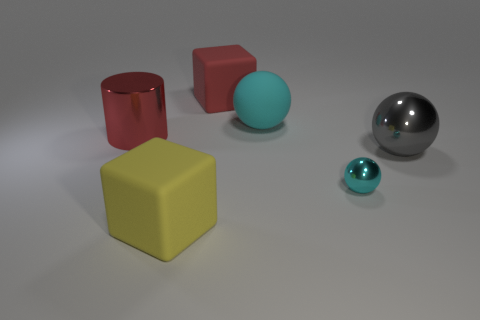What is the size of the thing that is the same color as the big cylinder?
Make the answer very short. Large. What is the material of the big thing that is the same color as the metal cylinder?
Your response must be concise. Rubber. What is the material of the large cyan object that is the same shape as the big gray metallic thing?
Keep it short and to the point. Rubber. Are there any big cyan things in front of the cyan matte thing?
Keep it short and to the point. No. Are the big cube that is behind the cyan rubber sphere and the tiny cyan object made of the same material?
Provide a short and direct response. No. Is there another big metallic cylinder that has the same color as the cylinder?
Offer a terse response. No. What is the shape of the large cyan rubber thing?
Your answer should be very brief. Sphere. What color is the large shiny object that is on the left side of the large rubber cube that is in front of the gray thing?
Offer a very short reply. Red. How big is the red thing right of the red metallic object?
Provide a short and direct response. Large. Is there a large blue cylinder that has the same material as the yellow object?
Your answer should be very brief. No. 